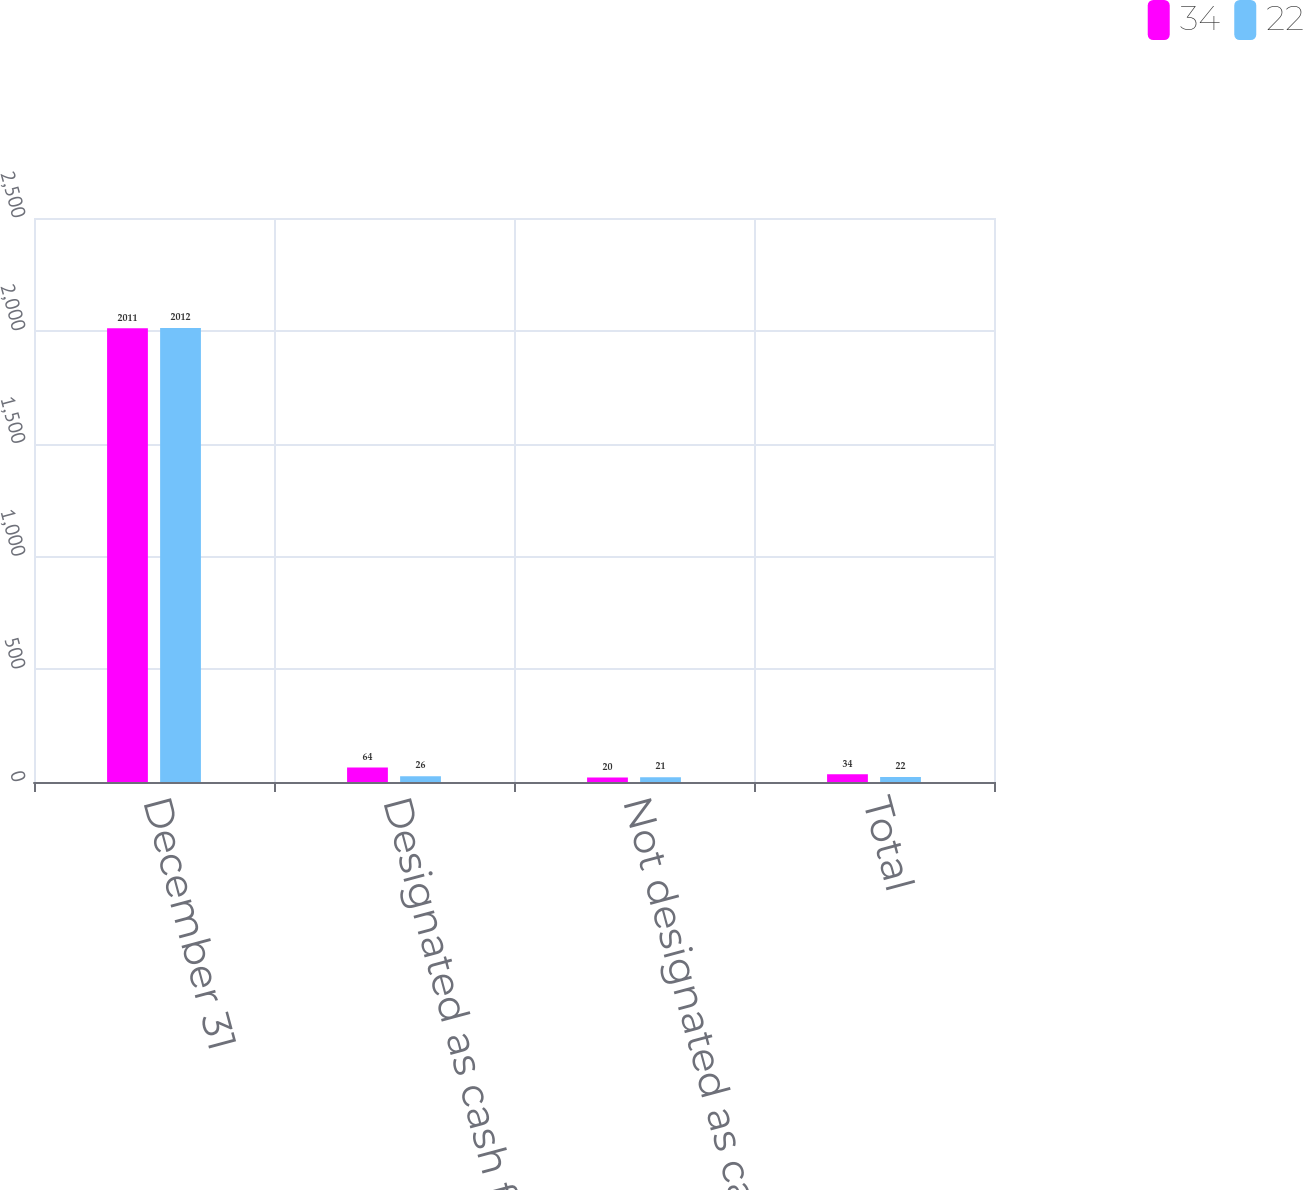Convert chart to OTSL. <chart><loc_0><loc_0><loc_500><loc_500><stacked_bar_chart><ecel><fcel>December 31<fcel>Designated as cash flow hedges<fcel>Not designated as cash flow<fcel>Total<nl><fcel>34<fcel>2011<fcel>64<fcel>20<fcel>34<nl><fcel>22<fcel>2012<fcel>26<fcel>21<fcel>22<nl></chart> 